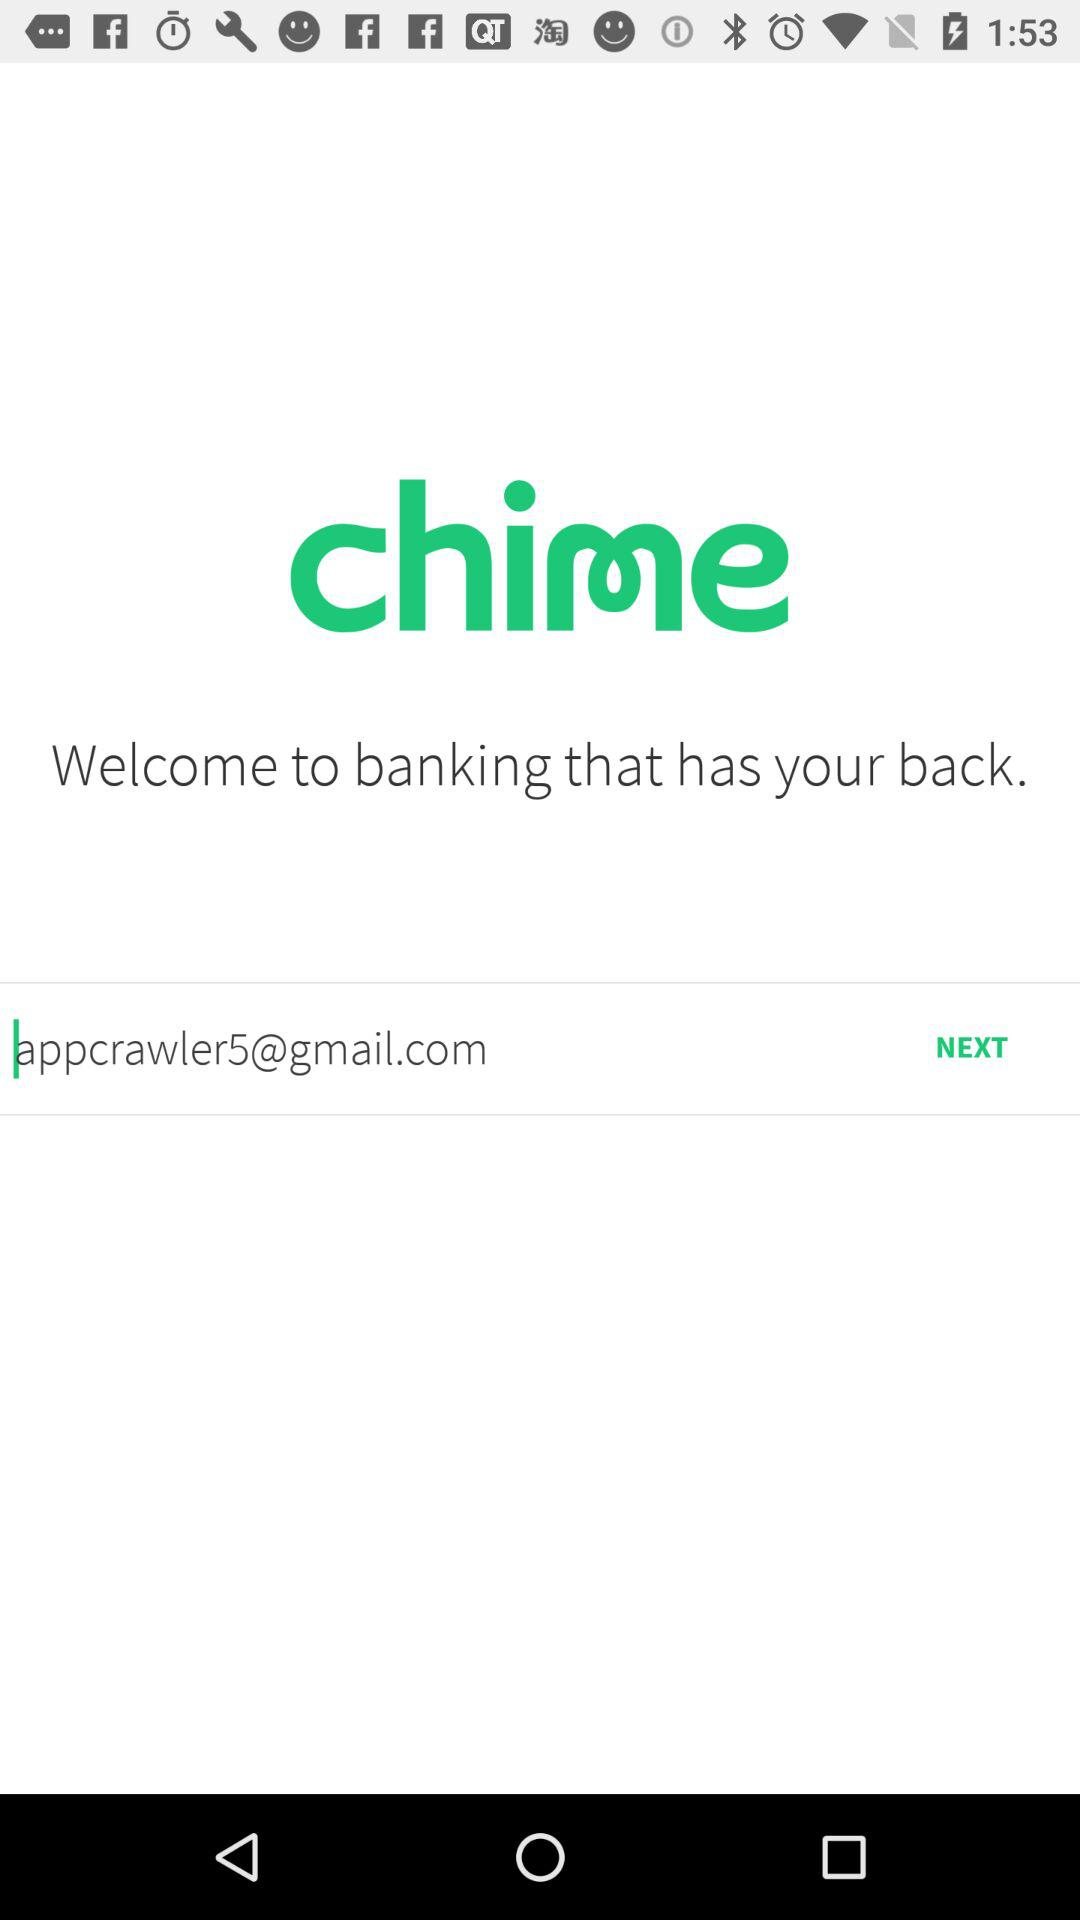How much money is in the user's account?
When the provided information is insufficient, respond with <no answer>. <no answer> 